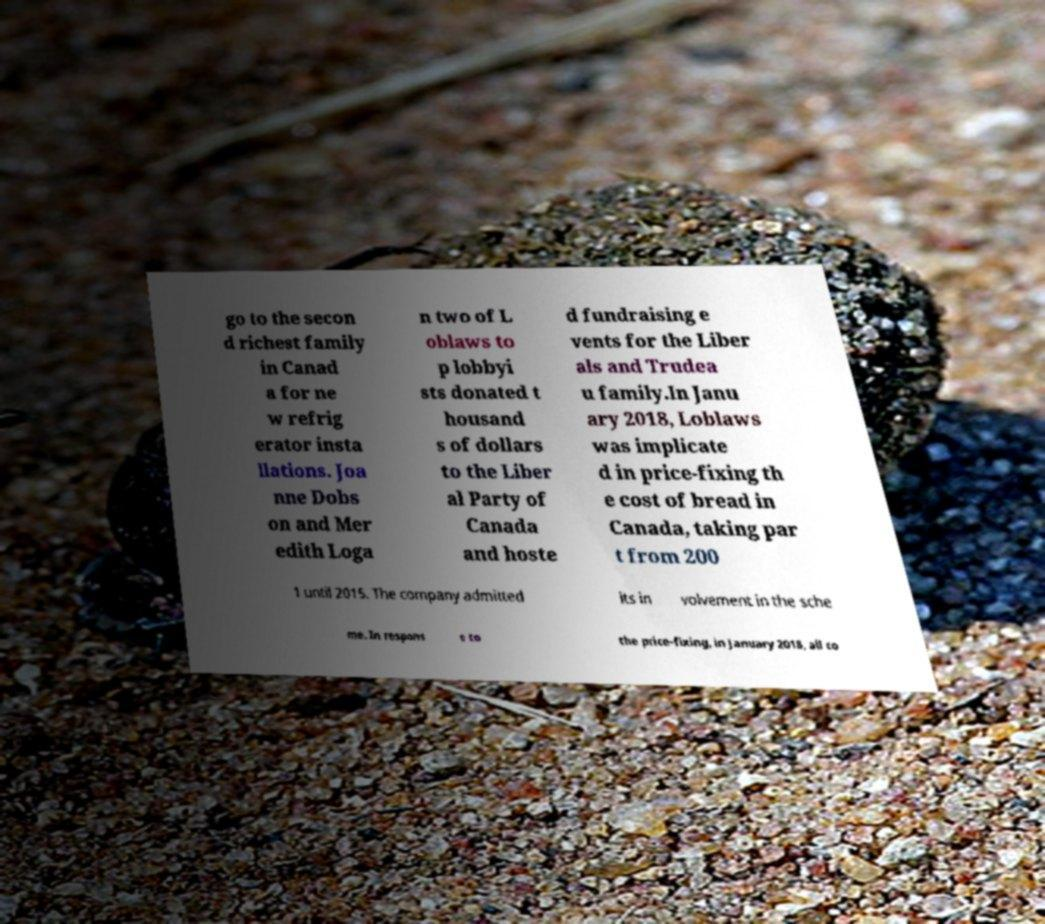Please identify and transcribe the text found in this image. go to the secon d richest family in Canad a for ne w refrig erator insta llations. Joa nne Dobs on and Mer edith Loga n two of L oblaws to p lobbyi sts donated t housand s of dollars to the Liber al Party of Canada and hoste d fundraising e vents for the Liber als and Trudea u family.In Janu ary 2018, Loblaws was implicate d in price-fixing th e cost of bread in Canada, taking par t from 200 1 until 2015. The company admitted its in volvement in the sche me. In respons e to the price-fixing, in January 2018, all co 